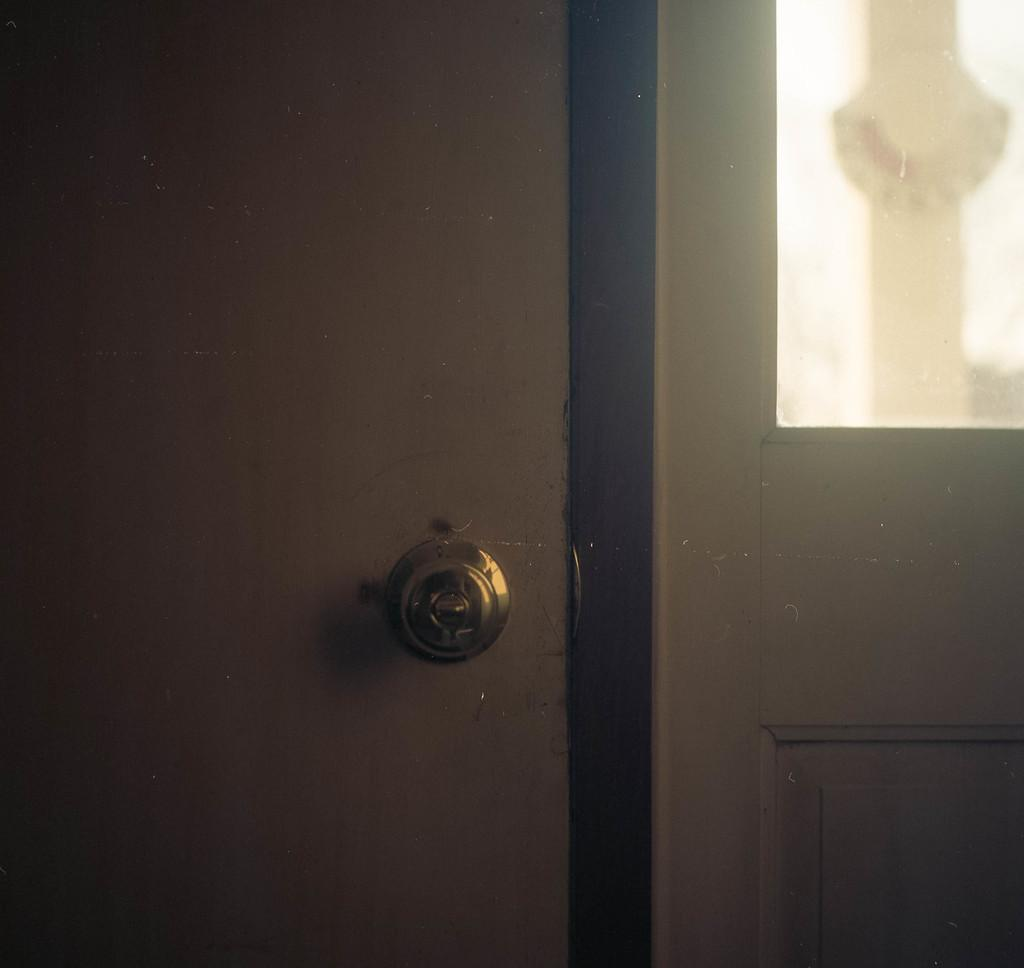What is the main object in the image? There is a door in the image. What type of plants can be seen growing near the door in the image? There is no information about plants in the image, as the only fact provided is about the door. 